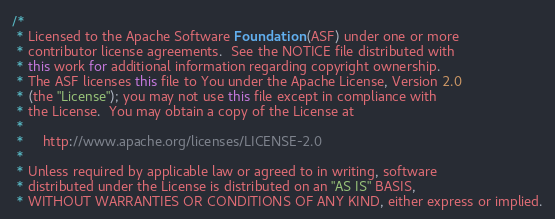Convert code to text. <code><loc_0><loc_0><loc_500><loc_500><_Java_>/*
 * Licensed to the Apache Software Foundation (ASF) under one or more
 * contributor license agreements.  See the NOTICE file distributed with
 * this work for additional information regarding copyright ownership.
 * The ASF licenses this file to You under the Apache License, Version 2.0
 * (the "License"); you may not use this file except in compliance with
 * the License.  You may obtain a copy of the License at
 *
 *     http://www.apache.org/licenses/LICENSE-2.0
 *
 * Unless required by applicable law or agreed to in writing, software
 * distributed under the License is distributed on an "AS IS" BASIS,
 * WITHOUT WARRANTIES OR CONDITIONS OF ANY KIND, either express or implied.</code> 